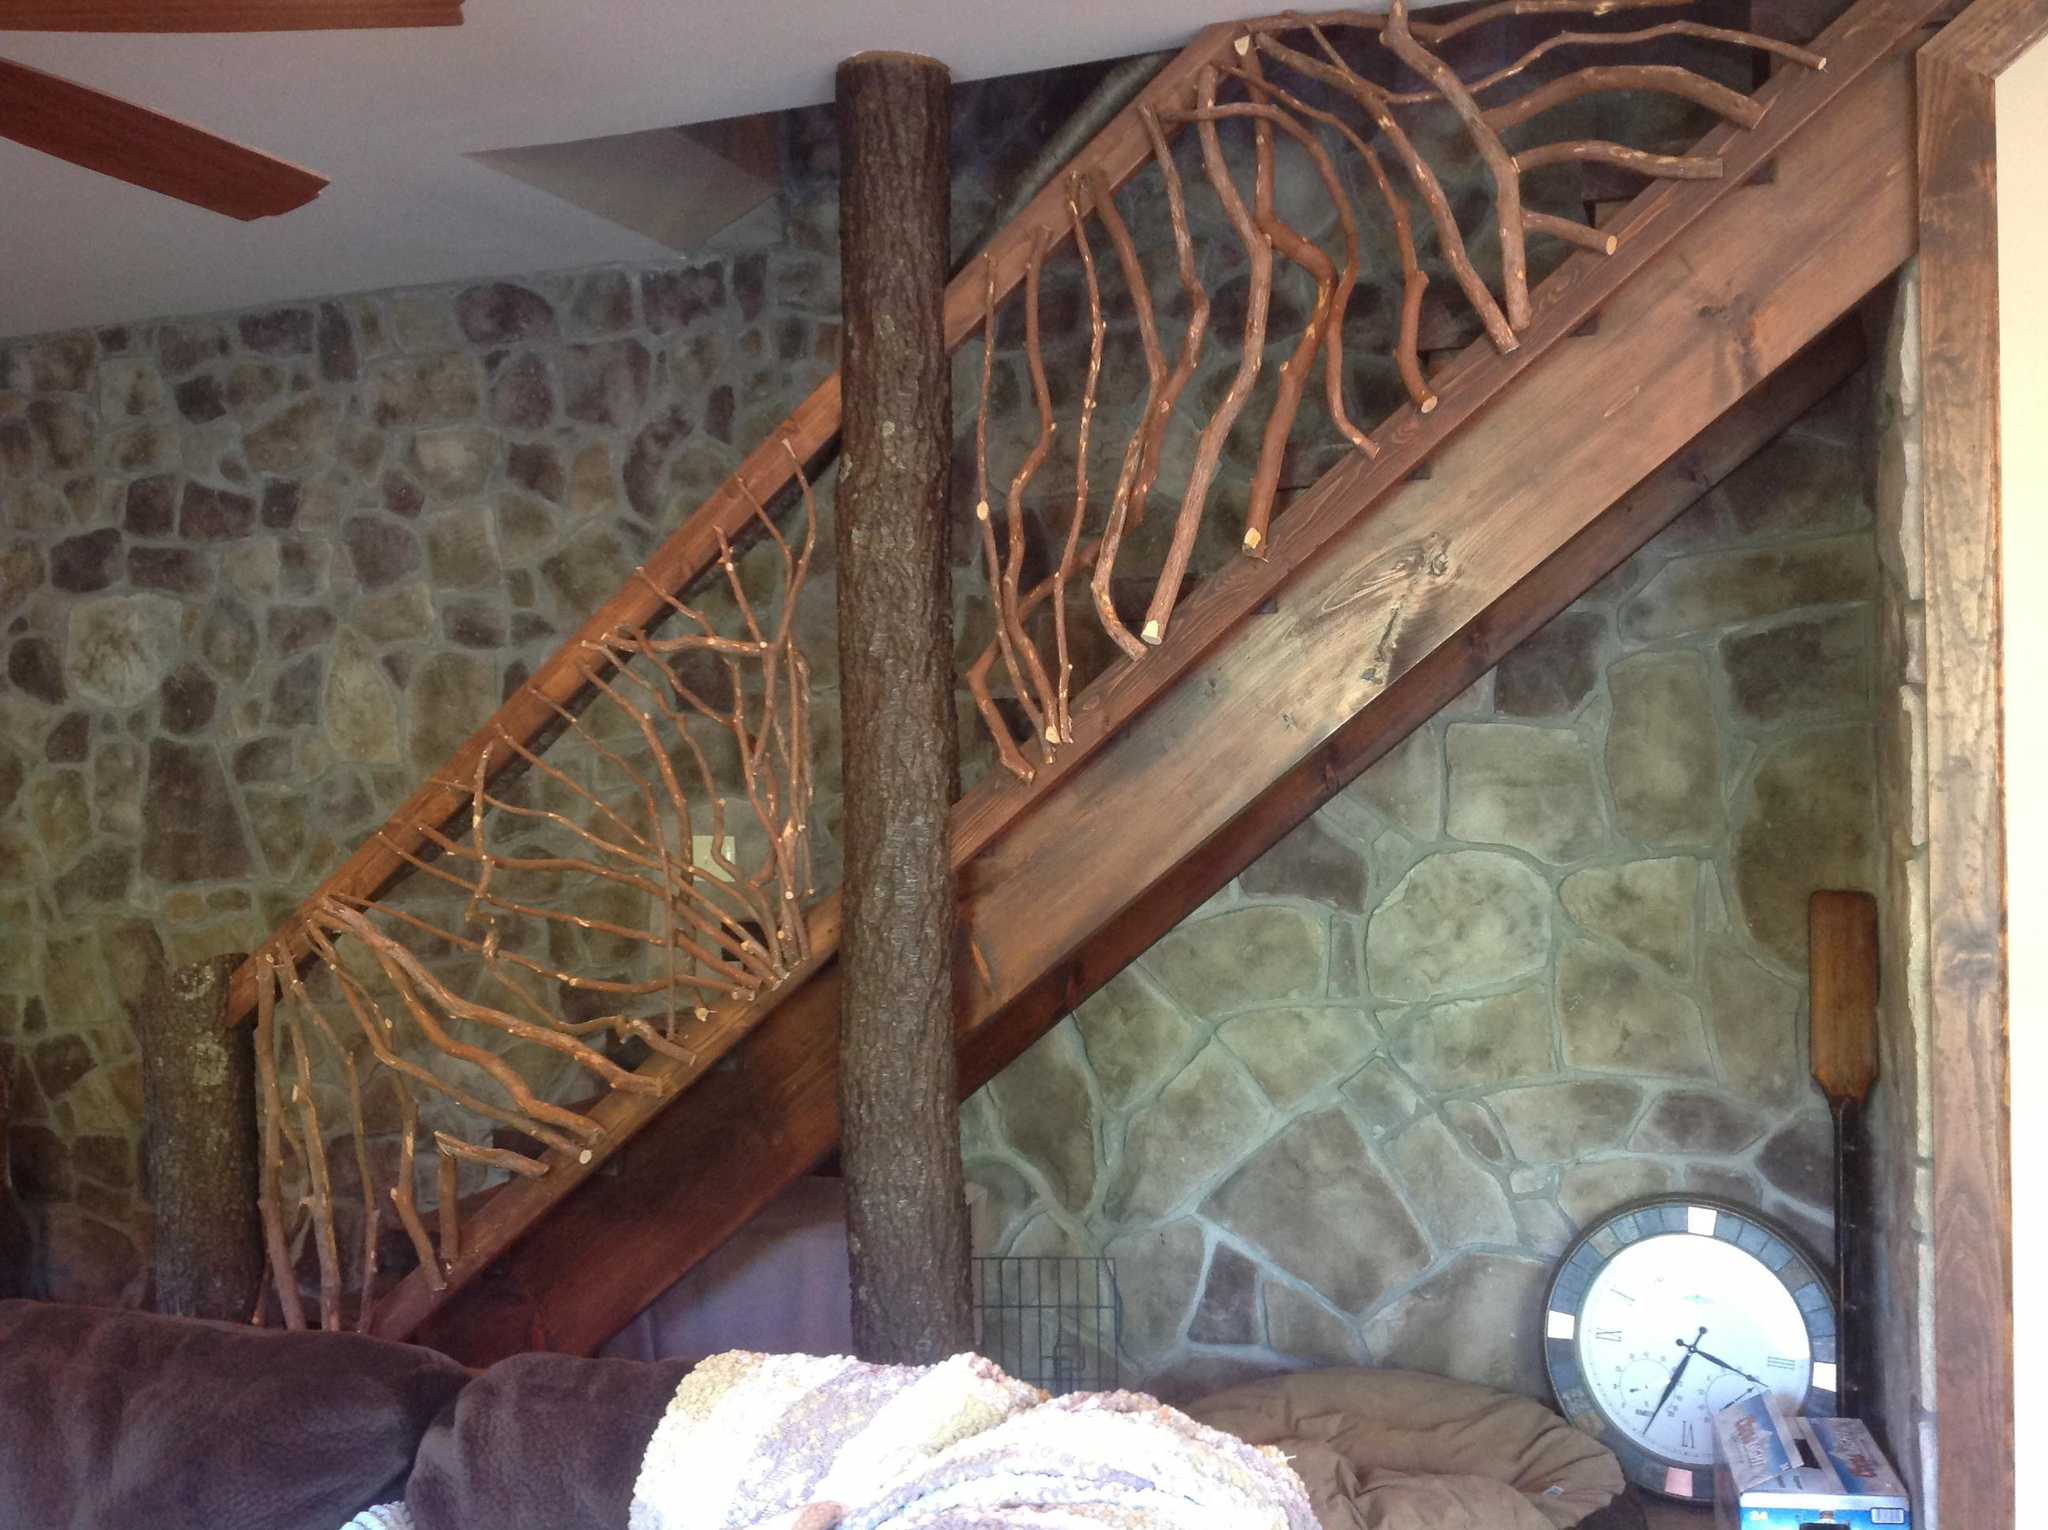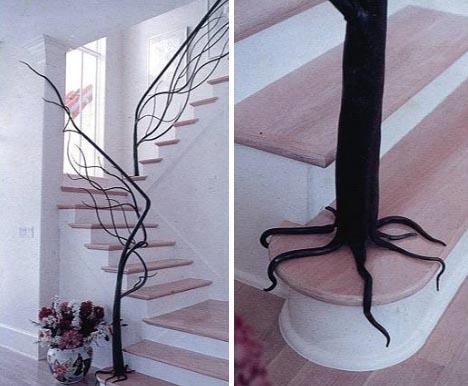The first image is the image on the left, the second image is the image on the right. Given the left and right images, does the statement "In the left image, a tree shape with a trunk at the base of the staircase has branches forming the railing as the stairs ascend rightward." hold true? Answer yes or no. No. 